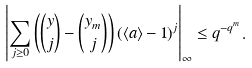Convert formula to latex. <formula><loc_0><loc_0><loc_500><loc_500>\left | \sum _ { j \geq 0 } \left ( \binom { y } { j } - \binom { y _ { m } } { j } \right ) ( \langle a \rangle - 1 ) ^ { j } \right | _ { \infty } \leq q ^ { - q ^ { m } } .</formula> 